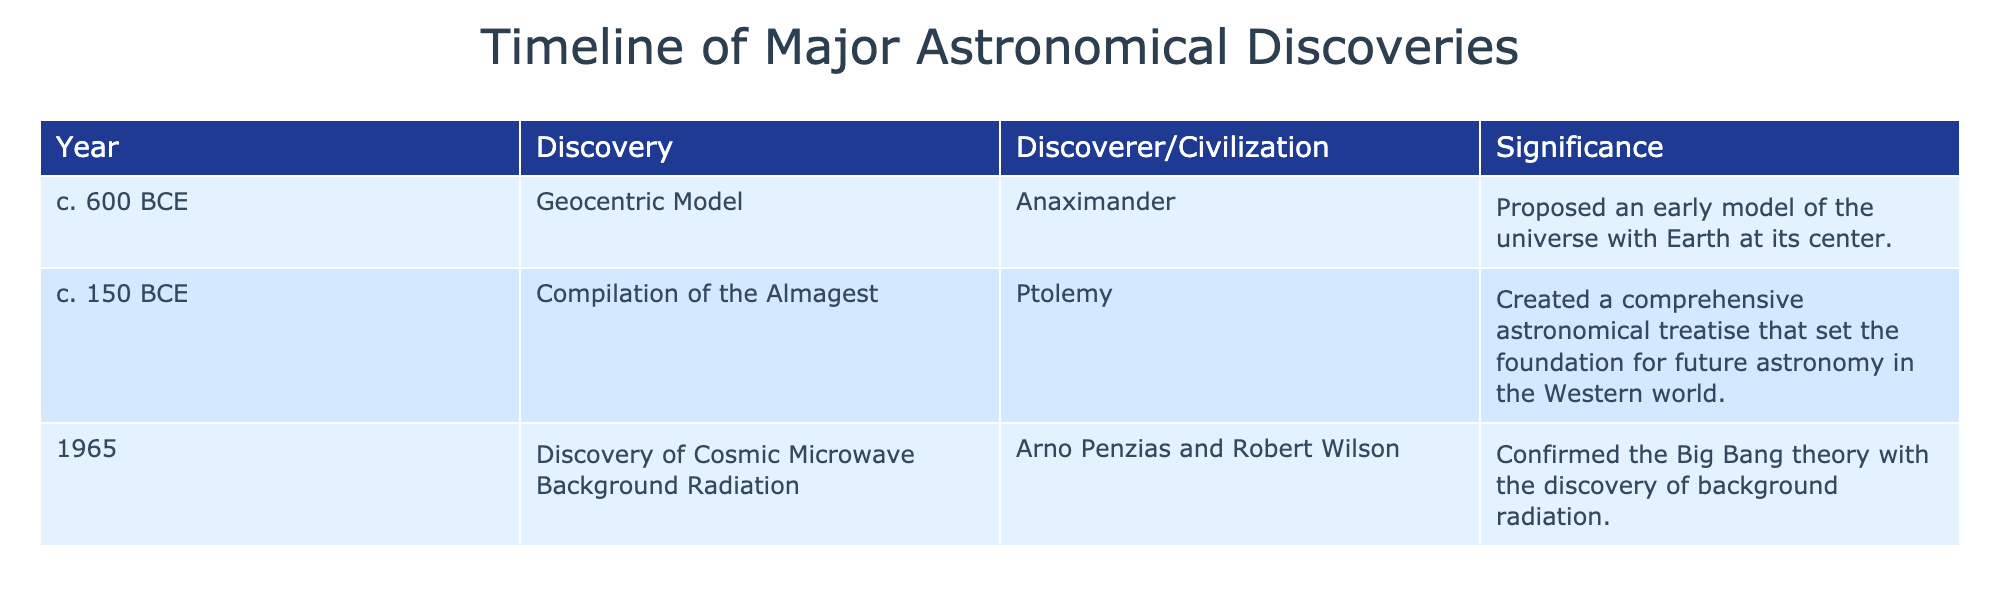What year was the geocentric model proposed? The table indicates that the geocentric model was proposed around 600 BCE.
Answer: 600 BCE Who discovered cosmic microwave background radiation? According to the table, cosmic microwave background radiation was discovered by Arno Penzias and Robert Wilson in 1965.
Answer: Arno Penzias and Robert Wilson What was the significance of the Almagest? The table states that the significance of the Almagest is that it created a comprehensive astronomical treatise that set the foundation for future astronomy in the Western world.
Answer: It set the foundation for future astronomy Was the geocentric model proposed after the compilation of the Almagest? The table shows that the geocentric model was proposed around 600 BCE, while the Almagest was compiled around 150 BCE, indicating the geocentric model was indeed proposed before.
Answer: No How many discoveries are listed in the table? By counting the entries in the table, there are three discoveries: the geocentric model, the Almagest, and the cosmic microwave background radiation.
Answer: 3 Which discovery occurred first, the geocentric model or the discovery of cosmic microwave background radiation? The geocentric model was proposed around 600 BCE, while the cosmic microwave background radiation was discovered in 1965. Therefore, the geocentric model occurred first.
Answer: Geocentric model What is the difference in years between the discovery of cosmic microwave background radiation and the compilation of the Almagest? The Almagest was compiled around 150 BCE and the cosmic microwave background radiation was discovered in 1965. First, convert 150 BCE to a negative number, -150, then calculate 1965 - (-150) gives 2115 years difference.
Answer: 2115 years Which discovery has the earliest date, and what was its significance? The earliest date in the table is 600 BCE for the geocentric model, which is significant for proposing an early model of the universe with Earth at its center.
Answer: Geocentric model; it proposed an early model of the universe How many discoveries were made in the 20th century compared to before? The table indicates that there were two discoveries (the Almagest and the geocentric model) made before the 20th century and one (the cosmic microwave background radiation) made in the 20th century.
Answer: 2 before, 1 in the 20th century What are the names of the discoverers for the discoveries listed? The table lists the discoverers as follows: Anaximander for the geocentric model, Ptolemy for the Almagest, and Arno Penzias and Robert Wilson for cosmic microwave background radiation.
Answer: Anaximander, Ptolemy, Arno Penzias and Robert Wilson 